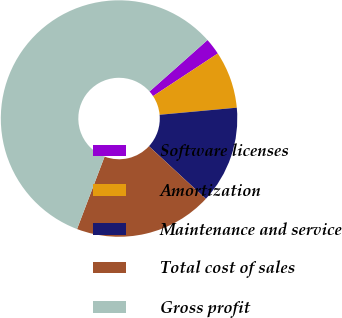Convert chart to OTSL. <chart><loc_0><loc_0><loc_500><loc_500><pie_chart><fcel>Software licenses<fcel>Amortization<fcel>Maintenance and service<fcel>Total cost of sales<fcel>Gross profit<nl><fcel>2.28%<fcel>7.81%<fcel>13.35%<fcel>18.89%<fcel>57.66%<nl></chart> 